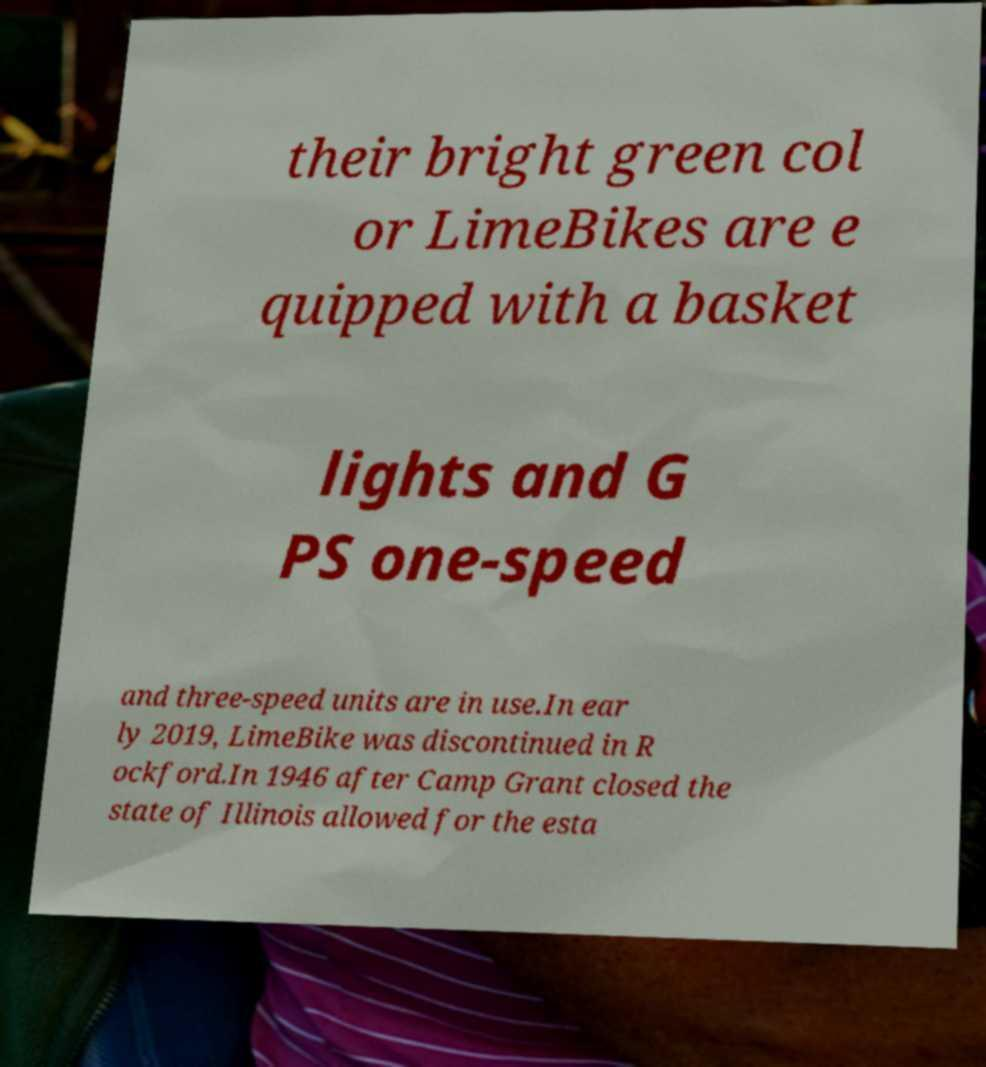I need the written content from this picture converted into text. Can you do that? their bright green col or LimeBikes are e quipped with a basket lights and G PS one-speed and three-speed units are in use.In ear ly 2019, LimeBike was discontinued in R ockford.In 1946 after Camp Grant closed the state of Illinois allowed for the esta 